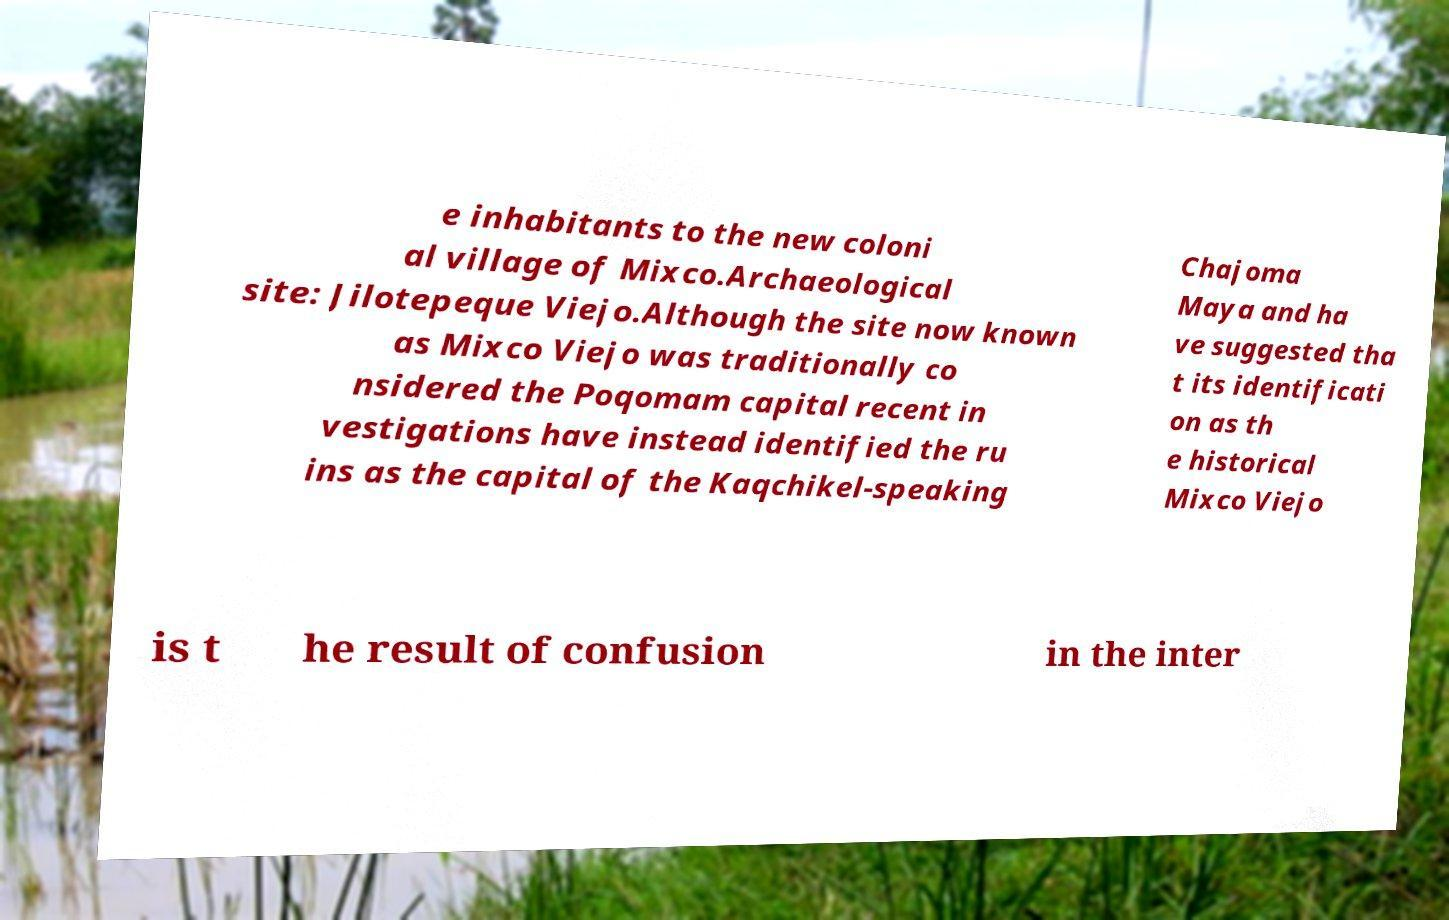I need the written content from this picture converted into text. Can you do that? e inhabitants to the new coloni al village of Mixco.Archaeological site: Jilotepeque Viejo.Although the site now known as Mixco Viejo was traditionally co nsidered the Poqomam capital recent in vestigations have instead identified the ru ins as the capital of the Kaqchikel-speaking Chajoma Maya and ha ve suggested tha t its identificati on as th e historical Mixco Viejo is t he result of confusion in the inter 